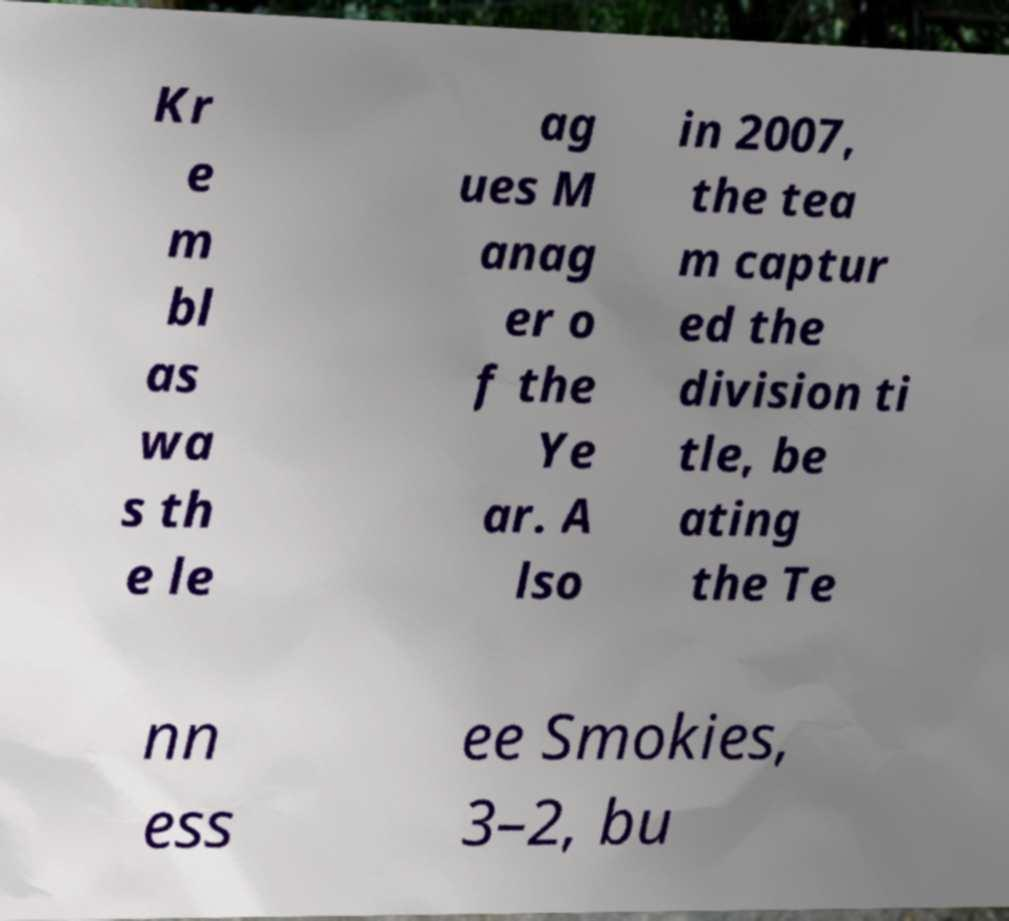Please read and relay the text visible in this image. What does it say? Kr e m bl as wa s th e le ag ues M anag er o f the Ye ar. A lso in 2007, the tea m captur ed the division ti tle, be ating the Te nn ess ee Smokies, 3–2, bu 